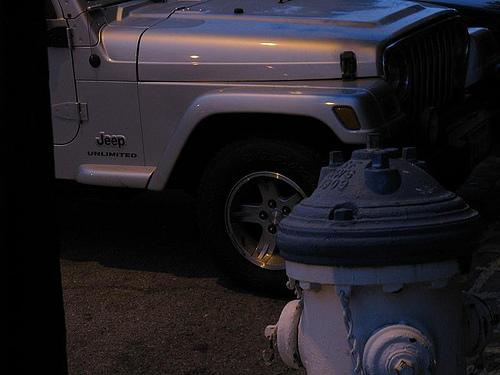State the color and location of the hose in the image. The hose is white in color and located at position (278, 149). Comment on the visual aspect of the ground in the image. The ground appears to be clear and grey in color, with a small black object in the sand. Provide a brief description focusing on the lights of the Jeep. The Jeep has a red side light indicator, a front light, and another light, all of different sizes. Enumerate any two nut/bolt objects in the image and their corresponding sizes. A nut on the machine has a size of 21x21 and a big bolt in the machine has a size of 76x76. Explain the wheel-related objects and their locations on the Jeep. There are two wheel objects on the Jeep - one with a size of 172x172 at position (201, 139), and another with a size of 132x132 at position (186, 147). Identify and describe the object located beside the Jeep. There is a grey capped hydrant with a chain next to the Jeep. Mention any two objects related to the Jeep's structure and their position. A side mirror at position (16, 13) and a black mark on the Jeep at position (81, 50) can be seen. Assess the image in terms of lighting and overall appearance. The image presents a beautiful view of the Jeep with light falling on it, giving a shiny appearance. What is the main vehicle presented in the image and what does the logo say on it? The main vehicle is a grey Jeep with a logo that says "Jeep Unlimited." Describe any additional information related to the objects in the image. The Jeep has a metallic shiny nature and a white water hose can be seen, as well as multiple instances of white chains around the hydrant. 